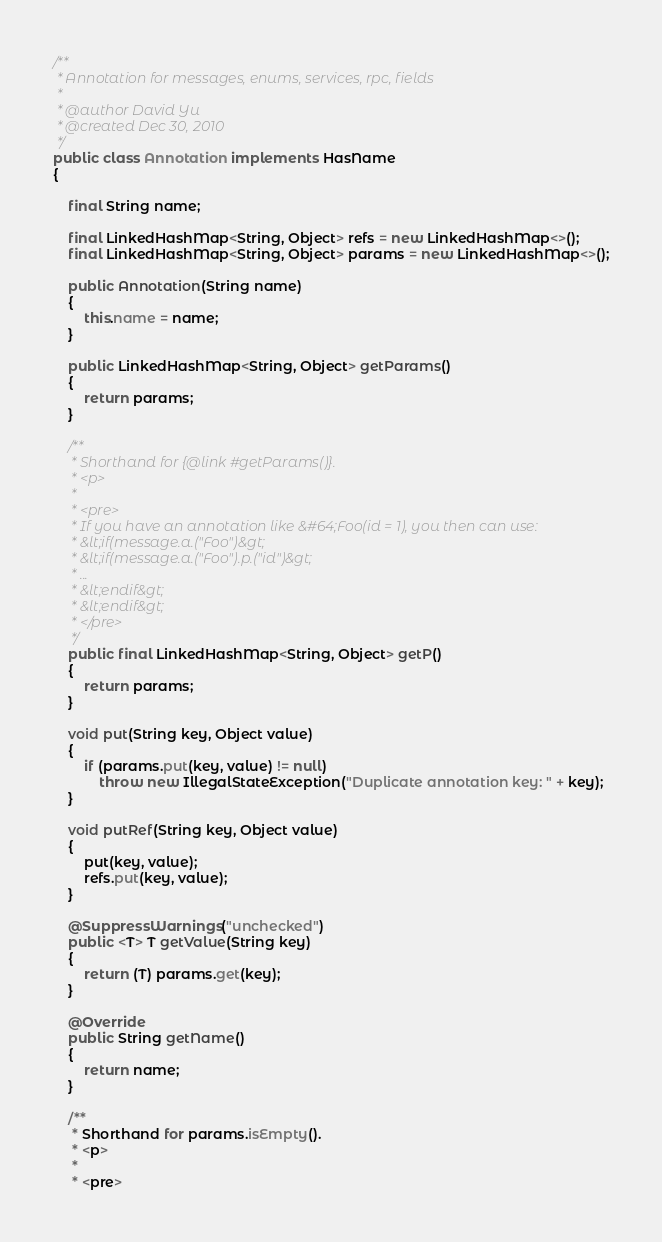<code> <loc_0><loc_0><loc_500><loc_500><_Java_>
/**
 * Annotation for messages, enums, services, rpc, fields
 * 
 * @author David Yu
 * @created Dec 30, 2010
 */
public class Annotation implements HasName
{

    final String name;

    final LinkedHashMap<String, Object> refs = new LinkedHashMap<>();
    final LinkedHashMap<String, Object> params = new LinkedHashMap<>();

    public Annotation(String name)
    {
        this.name = name;
    }

    public LinkedHashMap<String, Object> getParams()
    {
        return params;
    }

    /**
     * Shorthand for {@link #getParams()}.
     * <p>
     * 
     * <pre>
     * If you have an annotation like &#64;Foo(id = 1), you then can use:
     * &lt;if(message.a.("Foo")&gt;
     * &lt;if(message.a.("Foo").p.("id")&gt;
     * ...
     * &lt;endif&gt;
     * &lt;endif&gt;
     * </pre>
     */
    public final LinkedHashMap<String, Object> getP()
    {
        return params;
    }

    void put(String key, Object value)
    {
        if (params.put(key, value) != null)
            throw new IllegalStateException("Duplicate annotation key: " + key);
    }

    void putRef(String key, Object value)
    {
        put(key, value);
        refs.put(key, value);
    }

    @SuppressWarnings("unchecked")
    public <T> T getValue(String key)
    {
        return (T) params.get(key);
    }

    @Override
    public String getName()
    {
        return name;
    }

    /**
     * Shorthand for params.isEmpty().
     * <p>
     * 
     * <pre></code> 